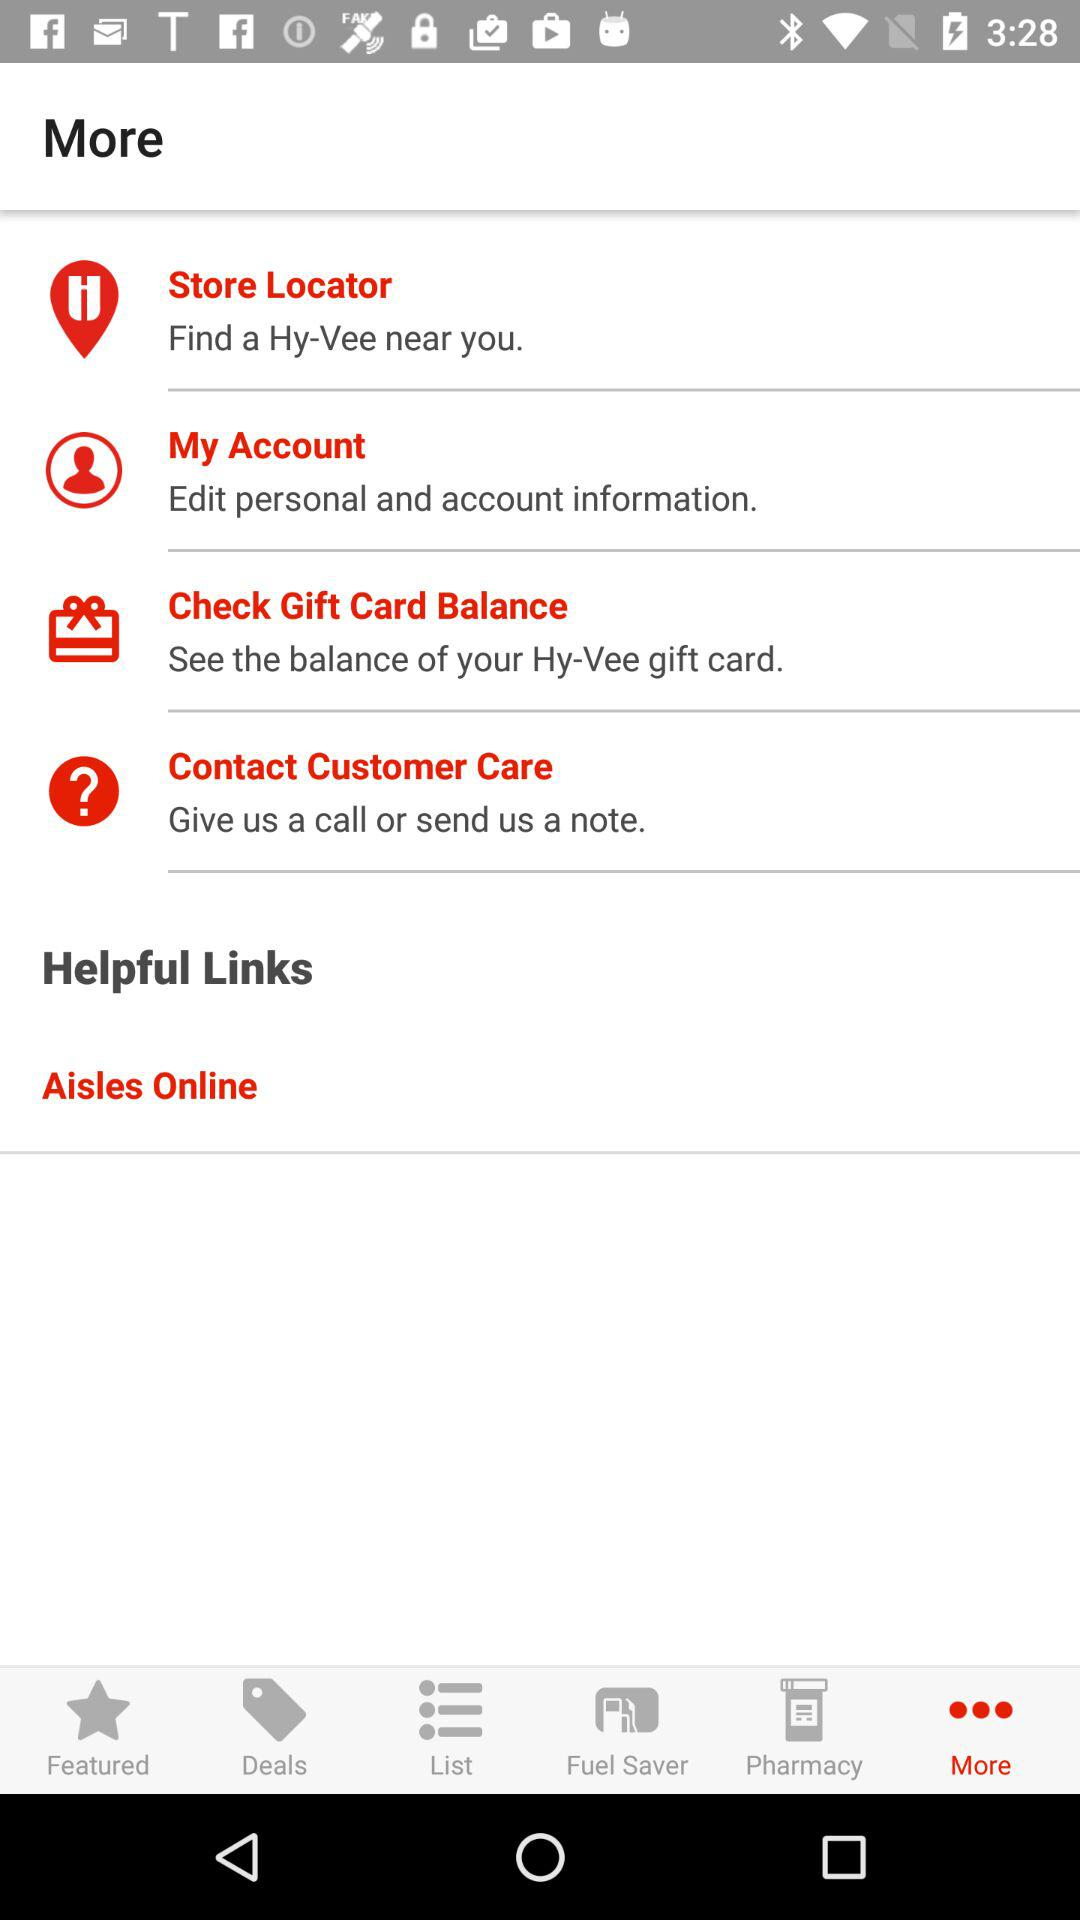How can we contact customer care? You can contact customer care by giving them a call or sending a note. 